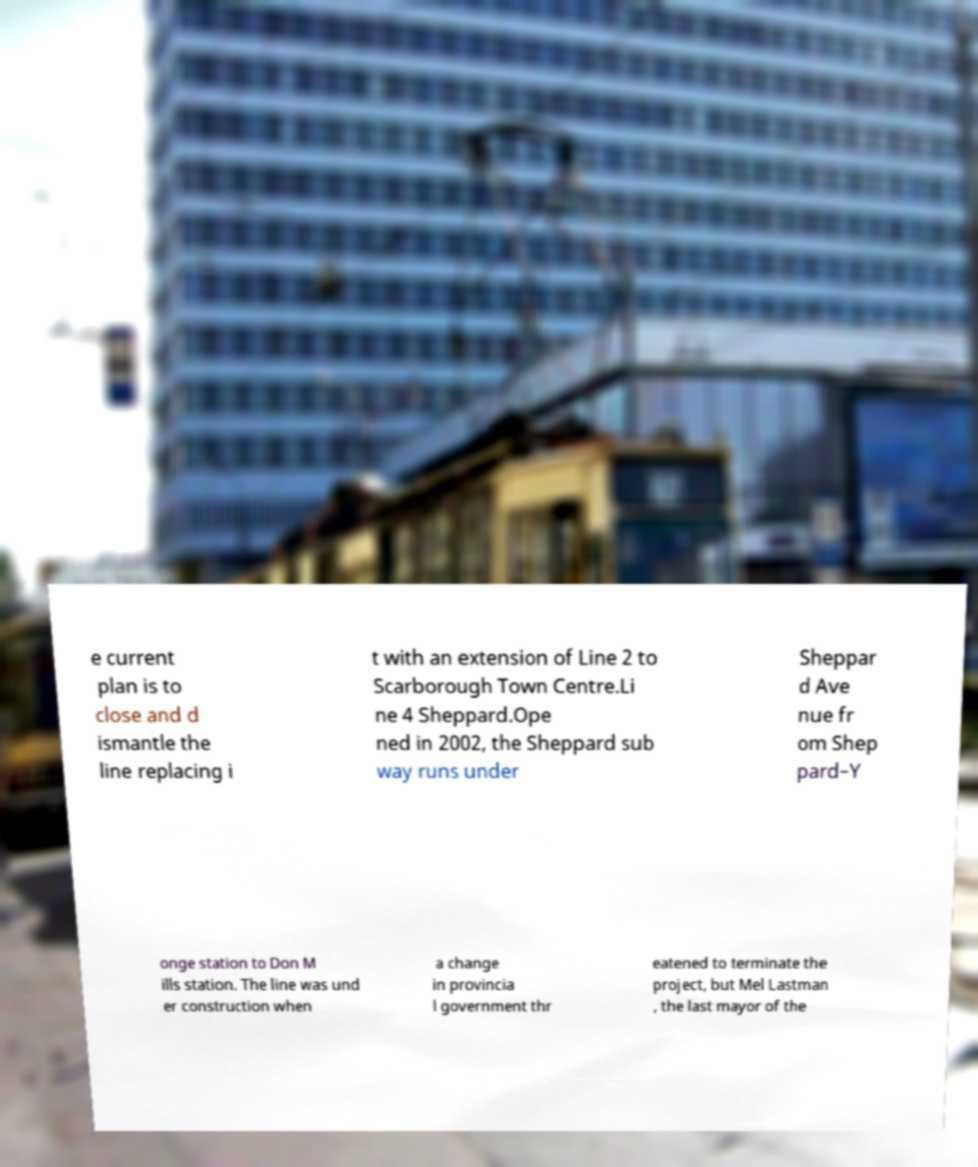I need the written content from this picture converted into text. Can you do that? e current plan is to close and d ismantle the line replacing i t with an extension of Line 2 to Scarborough Town Centre.Li ne 4 Sheppard.Ope ned in 2002, the Sheppard sub way runs under Sheppar d Ave nue fr om Shep pard–Y onge station to Don M ills station. The line was und er construction when a change in provincia l government thr eatened to terminate the project, but Mel Lastman , the last mayor of the 